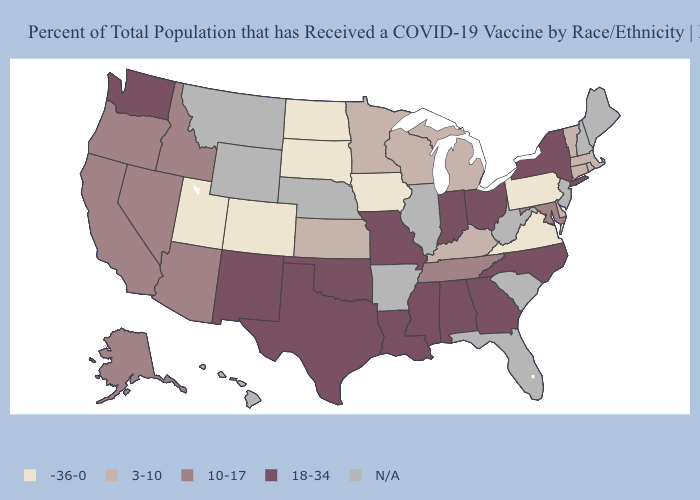What is the value of Alabama?
Quick response, please. 18-34. What is the lowest value in the Northeast?
Write a very short answer. -36-0. Does the map have missing data?
Write a very short answer. Yes. How many symbols are there in the legend?
Quick response, please. 5. Among the states that border Arkansas , which have the lowest value?
Write a very short answer. Tennessee. What is the lowest value in states that border Virginia?
Concise answer only. 3-10. Which states have the highest value in the USA?
Write a very short answer. Alabama, Georgia, Indiana, Louisiana, Mississippi, Missouri, New Mexico, New York, North Carolina, Ohio, Oklahoma, Texas, Washington. What is the value of Wyoming?
Concise answer only. N/A. Name the states that have a value in the range -36-0?
Keep it brief. Colorado, Iowa, North Dakota, Pennsylvania, South Dakota, Utah, Virginia. What is the highest value in the USA?
Give a very brief answer. 18-34. What is the value of Texas?
Concise answer only. 18-34. Is the legend a continuous bar?
Quick response, please. No. What is the value of Nebraska?
Quick response, please. N/A. Among the states that border Nevada , which have the highest value?
Quick response, please. Arizona, California, Idaho, Oregon. Does Tennessee have the highest value in the South?
Answer briefly. No. 